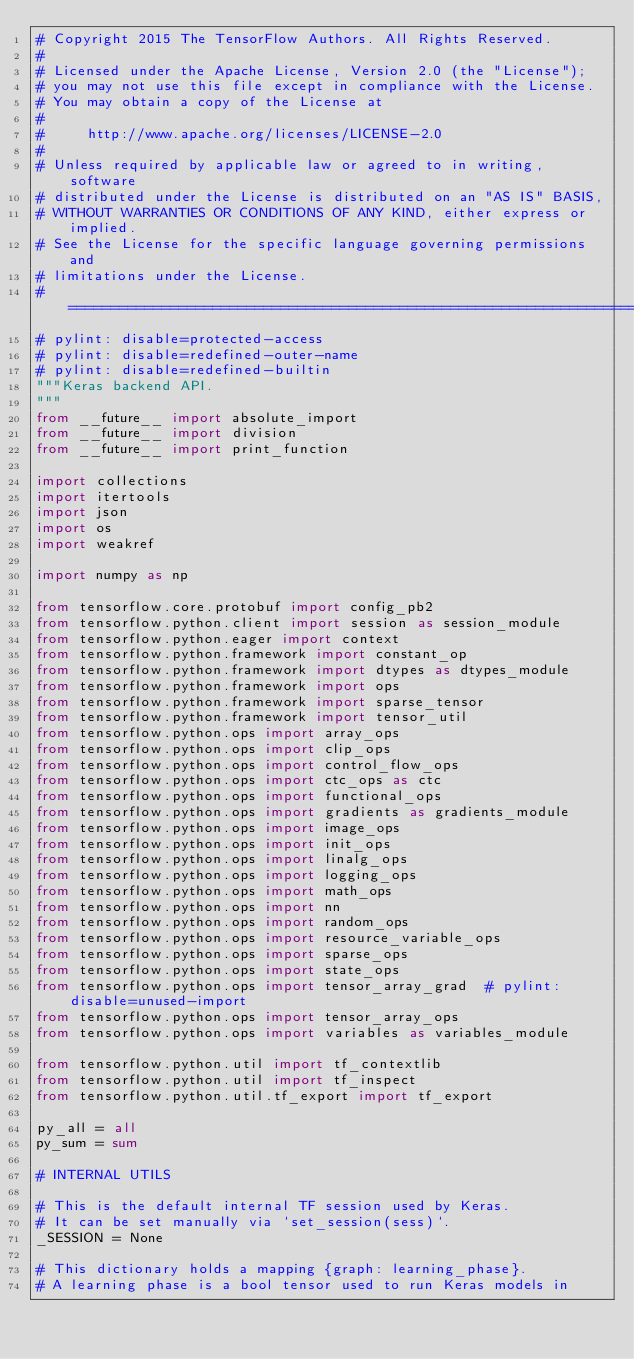Convert code to text. <code><loc_0><loc_0><loc_500><loc_500><_Python_># Copyright 2015 The TensorFlow Authors. All Rights Reserved.
#
# Licensed under the Apache License, Version 2.0 (the "License");
# you may not use this file except in compliance with the License.
# You may obtain a copy of the License at
#
#     http://www.apache.org/licenses/LICENSE-2.0
#
# Unless required by applicable law or agreed to in writing, software
# distributed under the License is distributed on an "AS IS" BASIS,
# WITHOUT WARRANTIES OR CONDITIONS OF ANY KIND, either express or implied.
# See the License for the specific language governing permissions and
# limitations under the License.
# ==============================================================================
# pylint: disable=protected-access
# pylint: disable=redefined-outer-name
# pylint: disable=redefined-builtin
"""Keras backend API.
"""
from __future__ import absolute_import
from __future__ import division
from __future__ import print_function

import collections
import itertools
import json
import os
import weakref

import numpy as np

from tensorflow.core.protobuf import config_pb2
from tensorflow.python.client import session as session_module
from tensorflow.python.eager import context
from tensorflow.python.framework import constant_op
from tensorflow.python.framework import dtypes as dtypes_module
from tensorflow.python.framework import ops
from tensorflow.python.framework import sparse_tensor
from tensorflow.python.framework import tensor_util
from tensorflow.python.ops import array_ops
from tensorflow.python.ops import clip_ops
from tensorflow.python.ops import control_flow_ops
from tensorflow.python.ops import ctc_ops as ctc
from tensorflow.python.ops import functional_ops
from tensorflow.python.ops import gradients as gradients_module
from tensorflow.python.ops import image_ops
from tensorflow.python.ops import init_ops
from tensorflow.python.ops import linalg_ops
from tensorflow.python.ops import logging_ops
from tensorflow.python.ops import math_ops
from tensorflow.python.ops import nn
from tensorflow.python.ops import random_ops
from tensorflow.python.ops import resource_variable_ops
from tensorflow.python.ops import sparse_ops
from tensorflow.python.ops import state_ops
from tensorflow.python.ops import tensor_array_grad  # pylint: disable=unused-import
from tensorflow.python.ops import tensor_array_ops
from tensorflow.python.ops import variables as variables_module

from tensorflow.python.util import tf_contextlib
from tensorflow.python.util import tf_inspect
from tensorflow.python.util.tf_export import tf_export

py_all = all
py_sum = sum

# INTERNAL UTILS

# This is the default internal TF session used by Keras.
# It can be set manually via `set_session(sess)`.
_SESSION = None

# This dictionary holds a mapping {graph: learning_phase}.
# A learning phase is a bool tensor used to run Keras models in</code> 